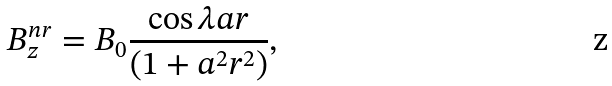<formula> <loc_0><loc_0><loc_500><loc_500>B _ { z } ^ { n r } = B _ { 0 } \frac { \cos \lambda a r } { ( 1 + a ^ { 2 } r ^ { 2 } ) } ,</formula> 